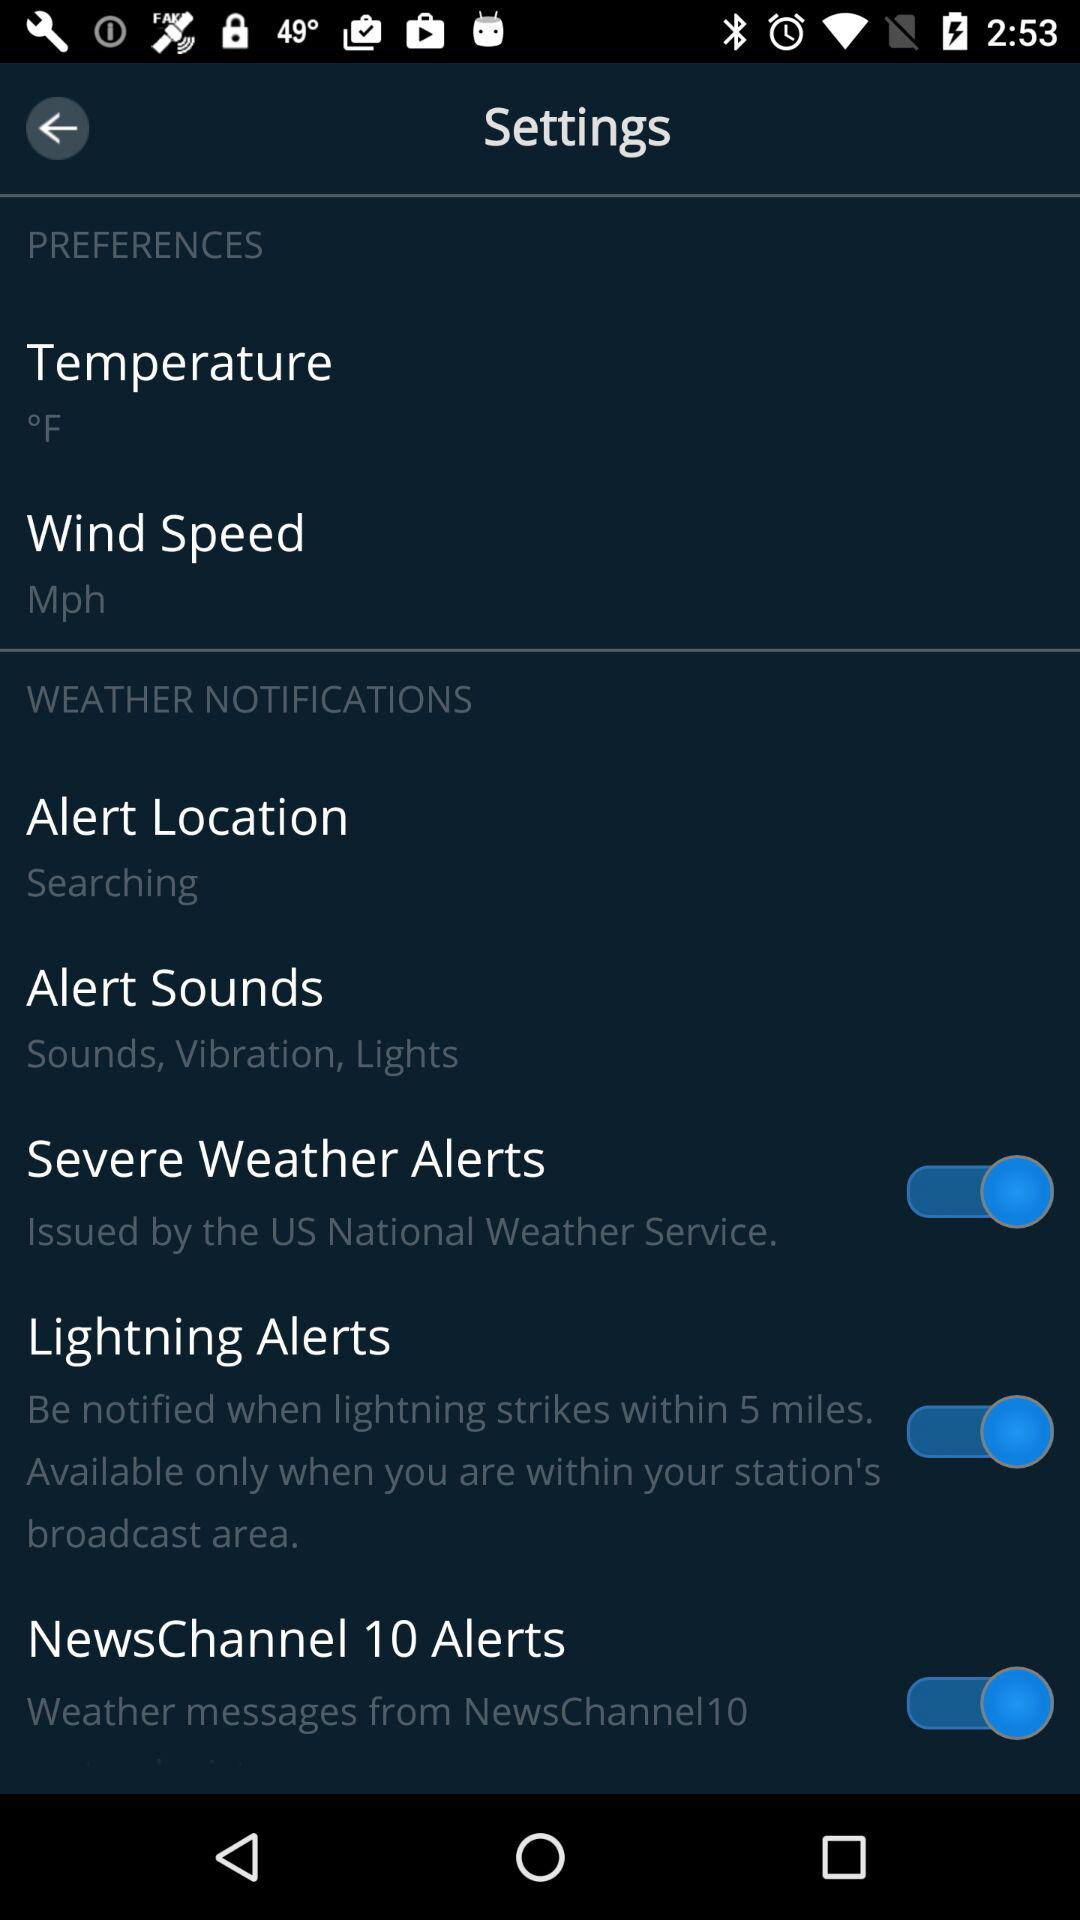What is the status of "Severe Weather Alerts"? The status of "Severe Weather Alerts" is "on". 